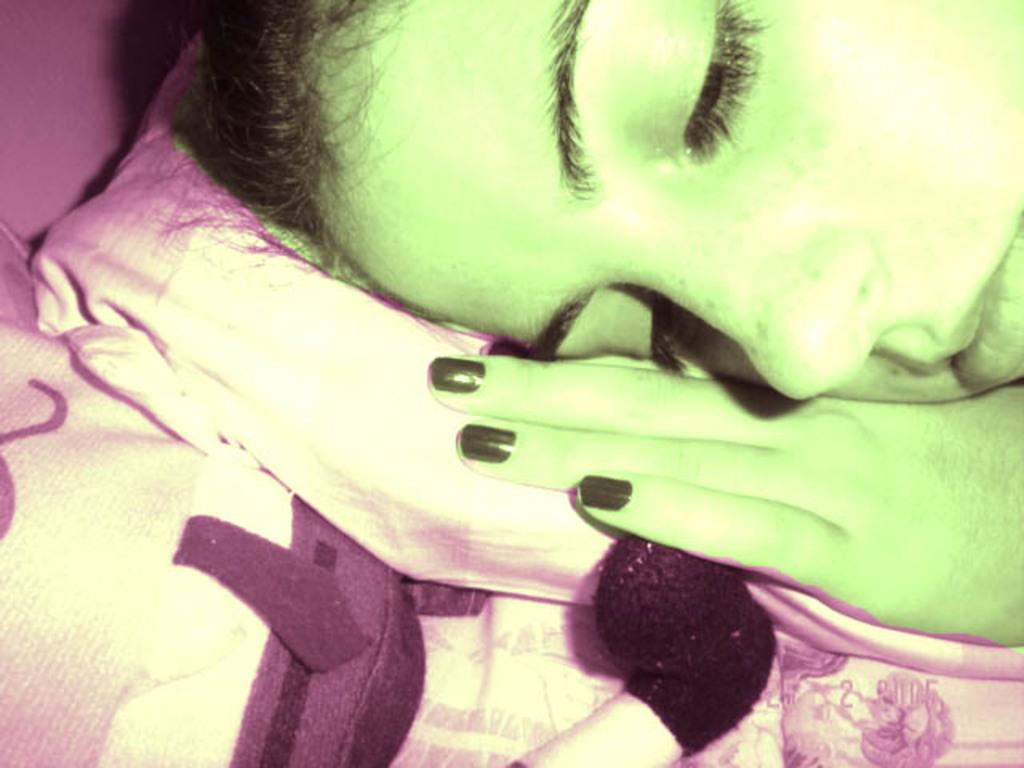What is the main subject of the image? There is a person's head in the image. Where is the person's head positioned? The person's head is on a pillow. What is the pillow placed on? The pillow is placed on a bed. What can be observed about the person's nails in the image? The person has black nail polish on their nails. What is the color of the bed sheet in the image? The bed sheet is white in color. Can you see the person's face clearly in the image? The image only shows the person's head, and it is not possible to see their face clearly. Is there a rat visible in the image? There is no rat present in the image. 